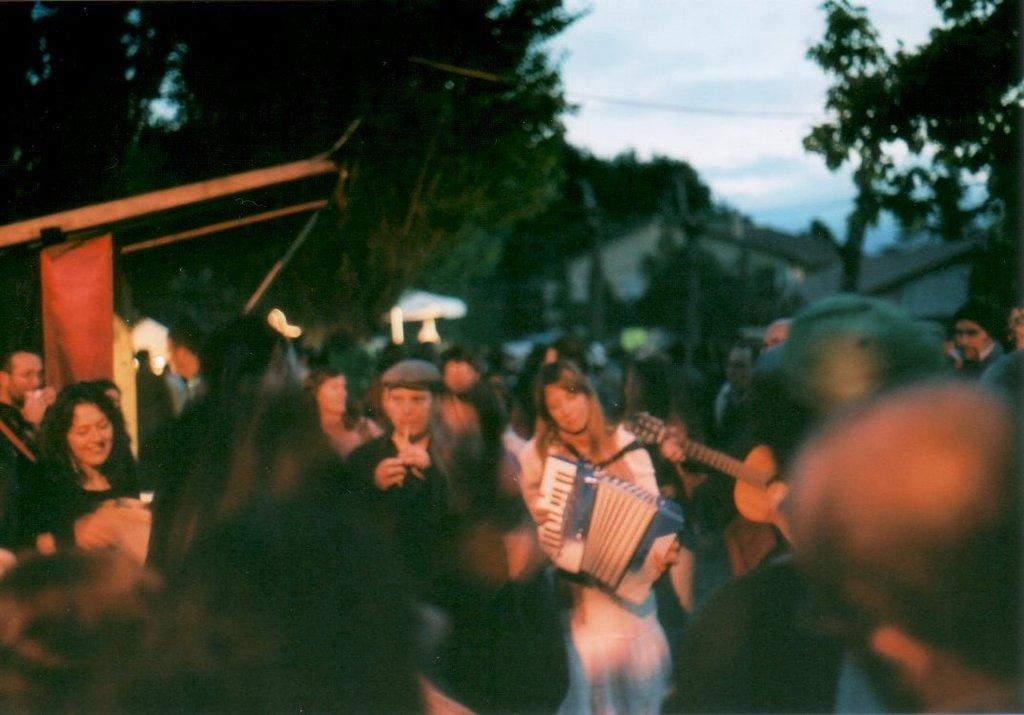What are the persons in the image doing? The persons in the image are playing music. What can be seen in the background of the image? There is a tree in the background of the image. What is visible in the sky in the image? The sky is visible in the image. How much tax is being collected from the beggar in the image? There is no beggar present in the image, and therefore no tax collection can be observed. 